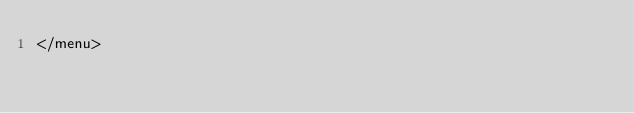<code> <loc_0><loc_0><loc_500><loc_500><_XML_></menu>
</code> 